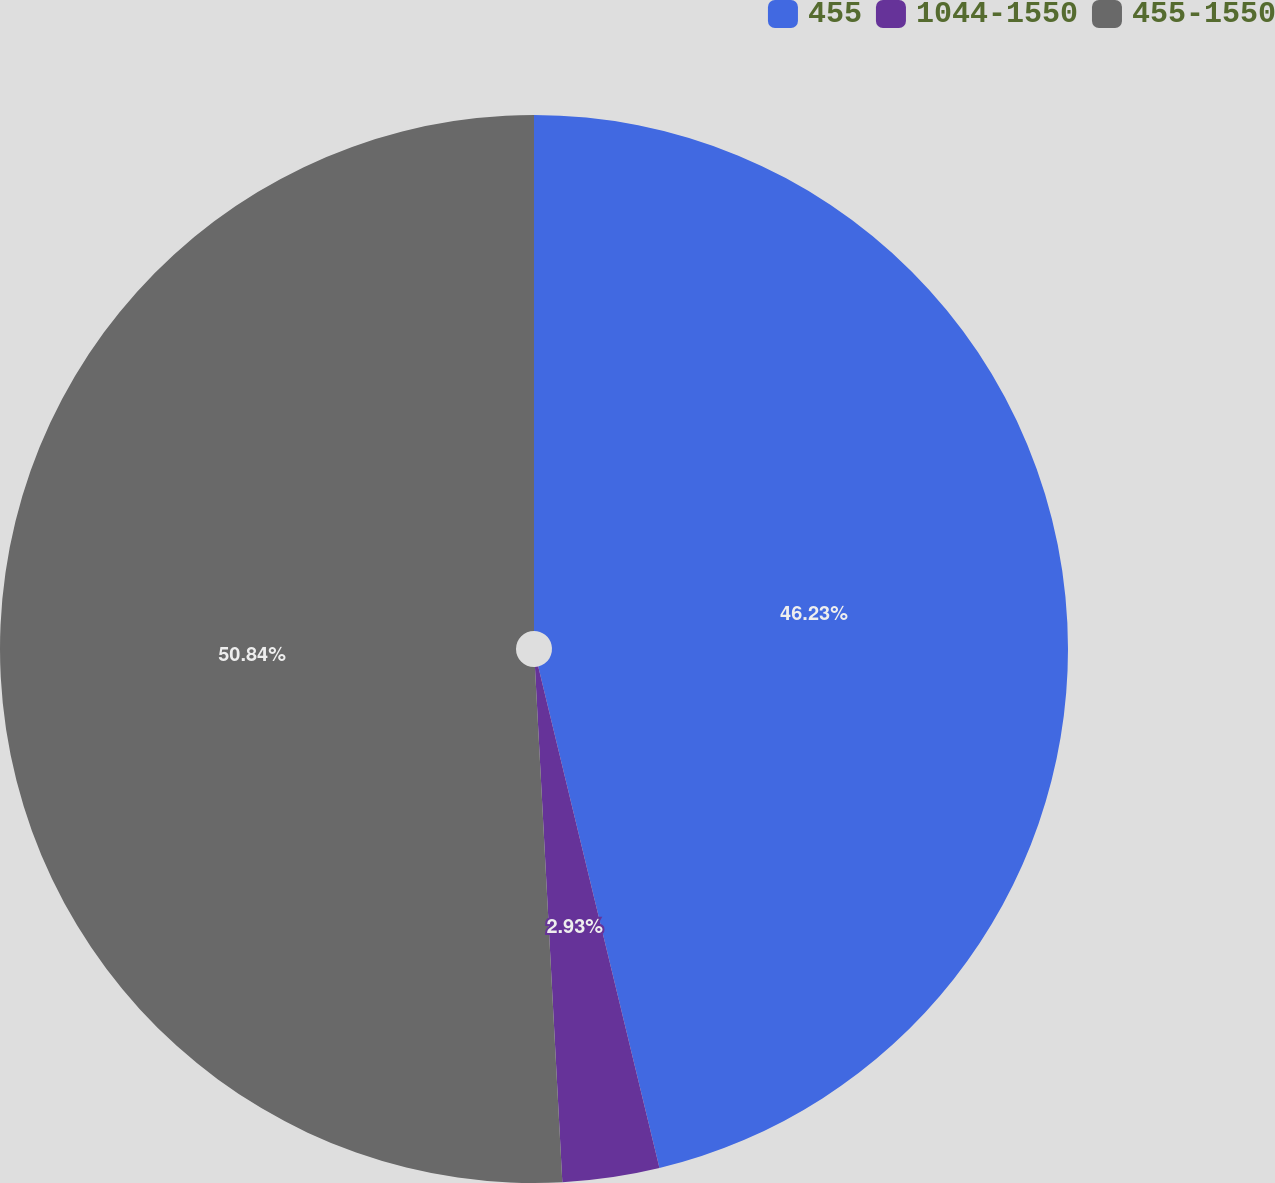Convert chart. <chart><loc_0><loc_0><loc_500><loc_500><pie_chart><fcel>455<fcel>1044-1550<fcel>455-1550<nl><fcel>46.23%<fcel>2.93%<fcel>50.85%<nl></chart> 